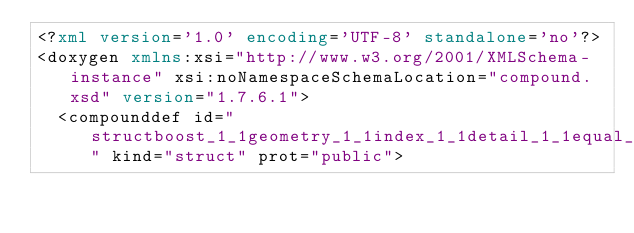Convert code to text. <code><loc_0><loc_0><loc_500><loc_500><_XML_><?xml version='1.0' encoding='UTF-8' standalone='no'?>
<doxygen xmlns:xsi="http://www.w3.org/2001/XMLSchema-instance" xsi:noNamespaceSchemaLocation="compound.xsd" version="1.7.6.1">
  <compounddef id="structboost_1_1geometry_1_1index_1_1detail_1_1equal__to_3_01std_1_1tuple_3_01_args_8_8_8_4_00_01false_01_4" kind="struct" prot="public"></code> 